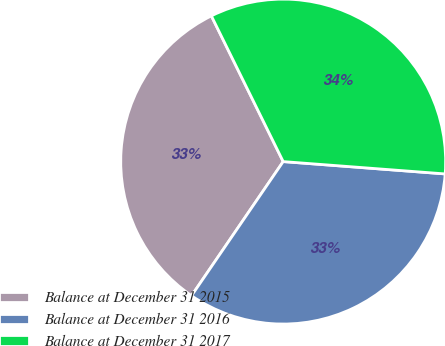<chart> <loc_0><loc_0><loc_500><loc_500><pie_chart><fcel>Balance at December 31 2015<fcel>Balance at December 31 2016<fcel>Balance at December 31 2017<nl><fcel>33.17%<fcel>33.33%<fcel>33.5%<nl></chart> 